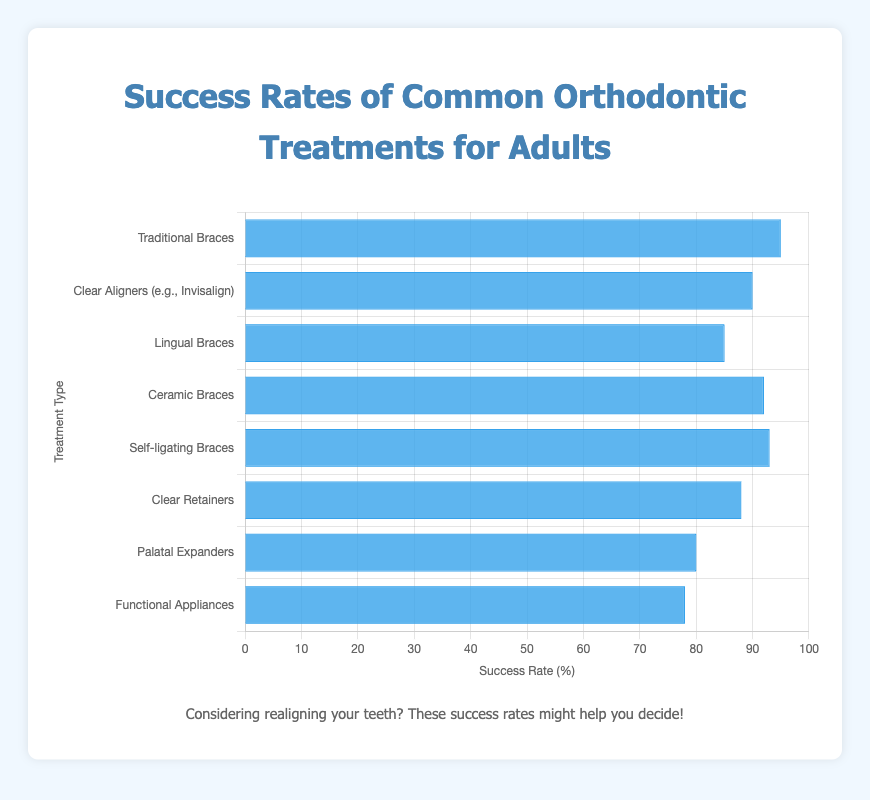Which orthodontic treatment has the highest success rate? The bar with the highest length indicates the treatment with the highest success rate. The "Traditional Braces" bar is tallest, indicating a 95% success rate.
Answer: Traditional Braces Which orthodontic treatment shows the lowest success rate? By comparing the heights of all the bars, the shortest bar belongs to "Functional Appliances," indicating a 78% success rate.
Answer: Functional Appliances How does the success rate of Clear Aligners compare to Traditional Braces? The height of the "Clear Aligners" bar is shorter than the "Traditional Braces" bar. Clear Aligners have a 90% success rate, while Traditional Braces have a 95% success rate.
Answer: Clear Aligners have a lower success rate than Traditional Braces Among Ceramic Braces, Self-ligating Braces, and Lingual Braces, which treatment has the highest success rate? By comparing the heights of the relevant bars, "Self-ligating Braces" has the highest bar with a 93% success rate. Ceramic Braces have 92%, and Lingual Braces have 85%.
Answer: Self-ligating Braces What's the total success rate when combining Clear Retainers and Palatal Expanders? Clear Retainers have a success rate of 88%, and Palatal Expanders have 80%. Adding both gives 88 + 80 = 168%.
Answer: 168% What's the average success rate of all the treatments? Add all the success rates and divide by the number of treatments. (95 + 90 + 85 + 92 + 93 + 88 + 80 + 78)/8 = 701/8 = 87.625%.
Answer: 87.625% What is the difference in success rate between the highest and lowest success rate treatments? The highest success rate is 95% (Traditional Braces) and the lowest is 78% (Functional Appliances). The difference is 95 - 78 = 17%.
Answer: 17% Which treatment types have a success rate of above 90%? By checking the heights of the bars above the 90% mark, "Traditional Braces" (95%), "Ceramic Braces" (92%), and "Self-ligating Braces" (93%) exceed 90%.
Answer: Traditional Braces, Ceramic Braces, Self-ligating Braces 